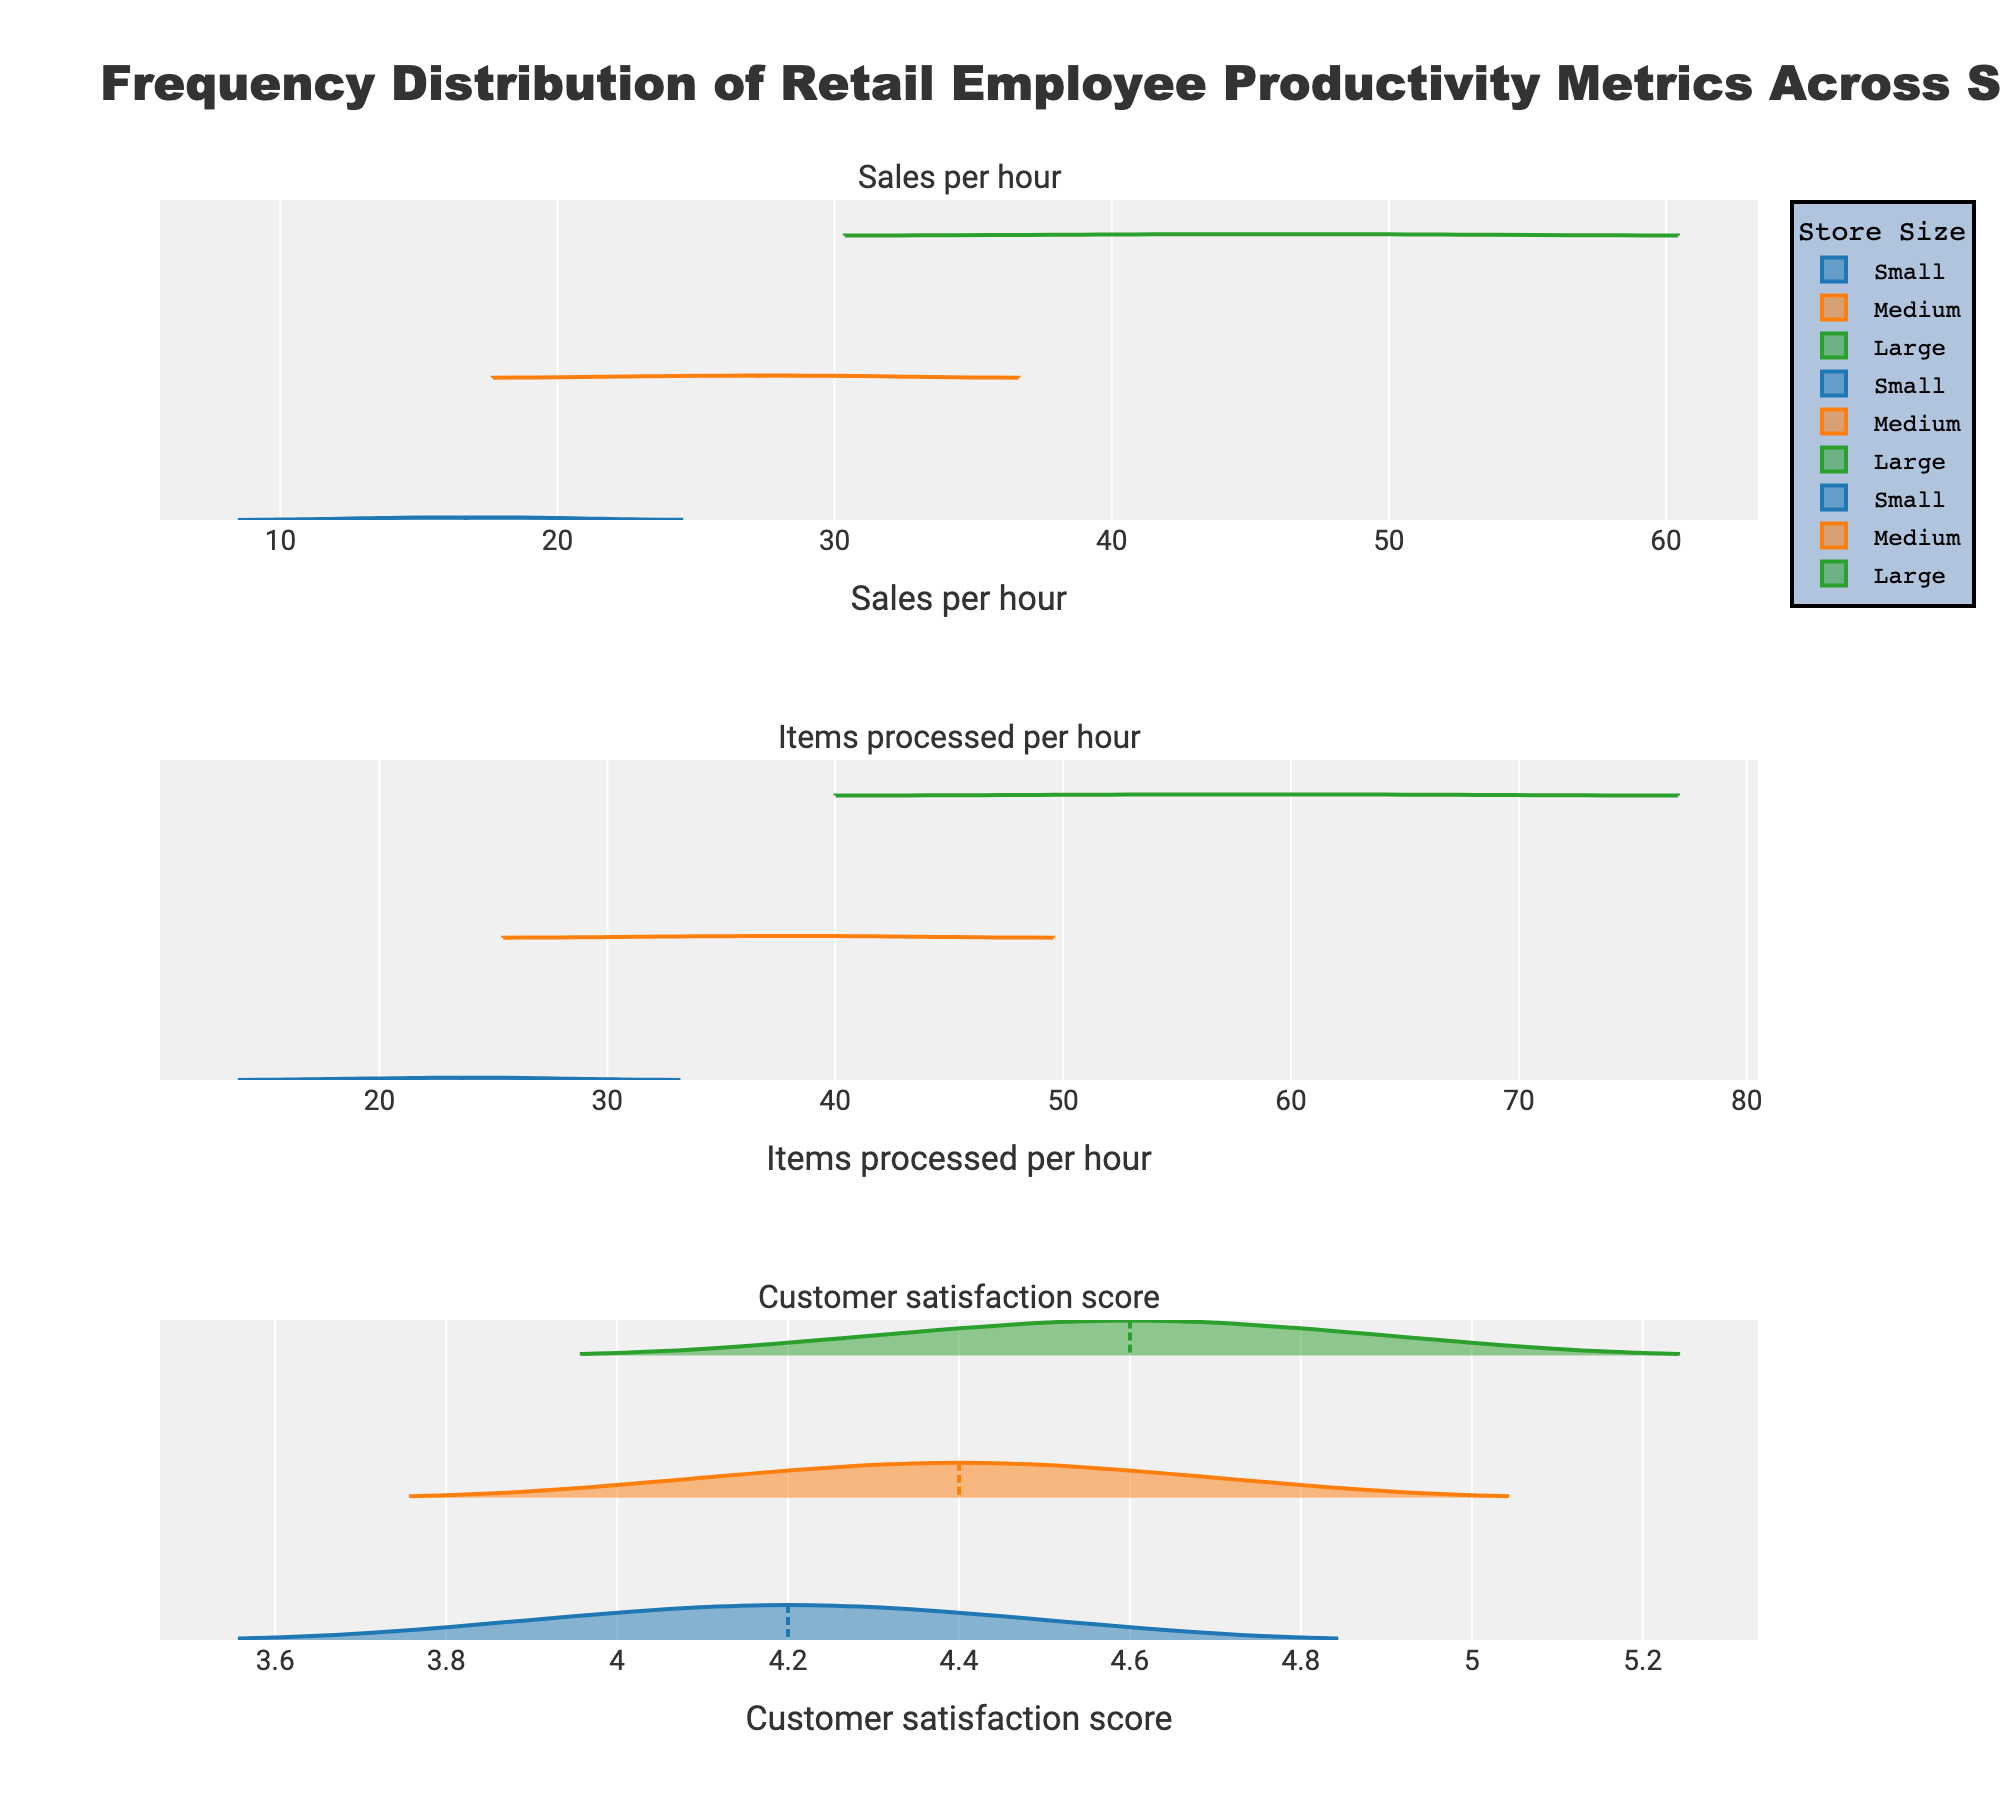What is the title of the figure? The title of the figure is located at the top of the plot. It reads "Frequency Distribution of Retail Employee Productivity Metrics Across Store Sizes".
Answer: Frequency Distribution of Retail Employee Productivity Metrics Across Store Sizes What are the x-axis titles of the subplots? Each subplot has its own x-axis title, which corresponds to the productivity metric being plotted. These titles are "Sales per hour", "Items processed per hour", and "Customer satisfaction score" respectively.
Answer: Sales per hour, Items processed per hour, Customer satisfaction score Which store size has the highest mean for the "Sales per hour" metric? The mean values for the "Sales per hour" metric are indicated by the mean lines on the violins. The "Large" store size has the highest mean.
Answer: Large How does the "Items processed per hour" distribution for the "Small" store size compare to the "Large" store size? The "Items processed per hour" distribution for "Large" stores is shifted to the right compared to "Small" stores, indicating higher values.
Answer: Higher for Large Which store size shows the narrowest distribution for customer satisfaction scores? By observing the spread of the violins for "Customer satisfaction score", the "Small" store size shows the narrowest distribution, indicating less variability.
Answer: Small What is the color used for the "Medium" store size in the plots? Each store size is represented with a unique color across all plots. The "Medium" store size is represented by the color orange.
Answer: Orange What is the range of "Sales per hour" values for "Small" store sizes? The range can be seen from the minimum to maximum points of the "Small" store size violin plot for "Sales per hour", which spans from approximately 12.9 to 20.1.
Answer: 12.9 to 20.1 Which metric has the least variability across all store sizes? By comparing the spreads of the violins across all metrics, "Customer satisfaction score" shows the least variability for all store sizes.
Answer: Customer satisfaction score Are there any positive skewness visible in the distribution plots, and if so, for which metric and store size? Positive skewness is indicated by a longer tail to the right. The "Sales per hour" plot for the "Medium" store size shows positive skewness.
Answer: Sales per hour for Medium 